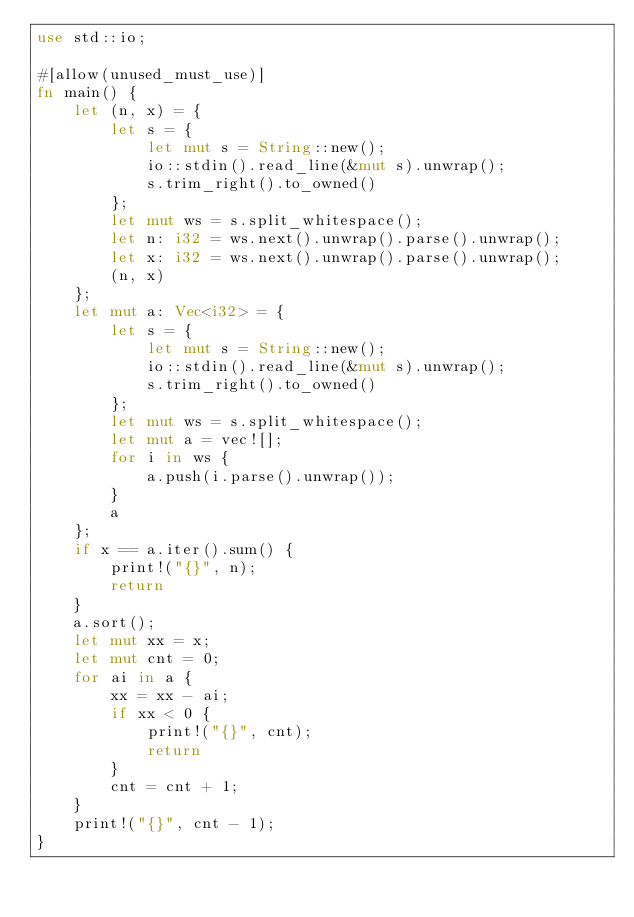Convert code to text. <code><loc_0><loc_0><loc_500><loc_500><_Rust_>use std::io;

#[allow(unused_must_use)]
fn main() {
    let (n, x) = {
        let s = {
            let mut s = String::new();
            io::stdin().read_line(&mut s).unwrap();
            s.trim_right().to_owned()
        };
        let mut ws = s.split_whitespace();
        let n: i32 = ws.next().unwrap().parse().unwrap();
        let x: i32 = ws.next().unwrap().parse().unwrap();
        (n, x)
    };
    let mut a: Vec<i32> = {
        let s = {
            let mut s = String::new();
            io::stdin().read_line(&mut s).unwrap();
            s.trim_right().to_owned()
        };
        let mut ws = s.split_whitespace();
        let mut a = vec![];
        for i in ws {
            a.push(i.parse().unwrap());
        }
        a
    };
    if x == a.iter().sum() {
        print!("{}", n);
        return
    }
    a.sort();
    let mut xx = x;
    let mut cnt = 0;
    for ai in a {
        xx = xx - ai;
        if xx < 0 {
            print!("{}", cnt);
            return
        }
        cnt = cnt + 1;
    }
    print!("{}", cnt - 1);
}
</code> 